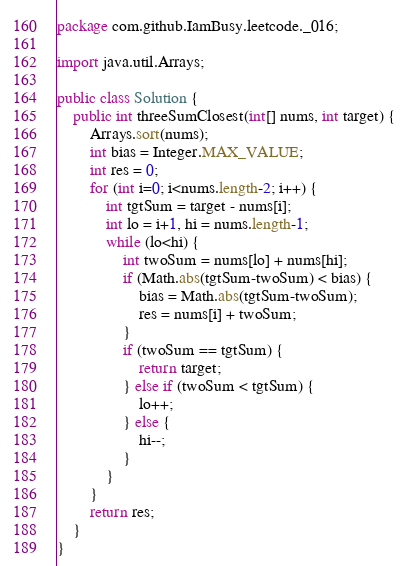<code> <loc_0><loc_0><loc_500><loc_500><_Java_>package com.github.IamBusy.leetcode._016;

import java.util.Arrays;

public class Solution {
    public int threeSumClosest(int[] nums, int target) {
        Arrays.sort(nums);
        int bias = Integer.MAX_VALUE;
        int res = 0;
        for (int i=0; i<nums.length-2; i++) {
            int tgtSum = target - nums[i];
            int lo = i+1, hi = nums.length-1;
            while (lo<hi) {
                int twoSum = nums[lo] + nums[hi];
                if (Math.abs(tgtSum-twoSum) < bias) {
                    bias = Math.abs(tgtSum-twoSum);
                    res = nums[i] + twoSum;
                }
                if (twoSum == tgtSum) {
                    return target;
                } else if (twoSum < tgtSum) {
                    lo++;
                } else {
                    hi--;
                }
            }
        }
        return res;
    }
}
</code> 